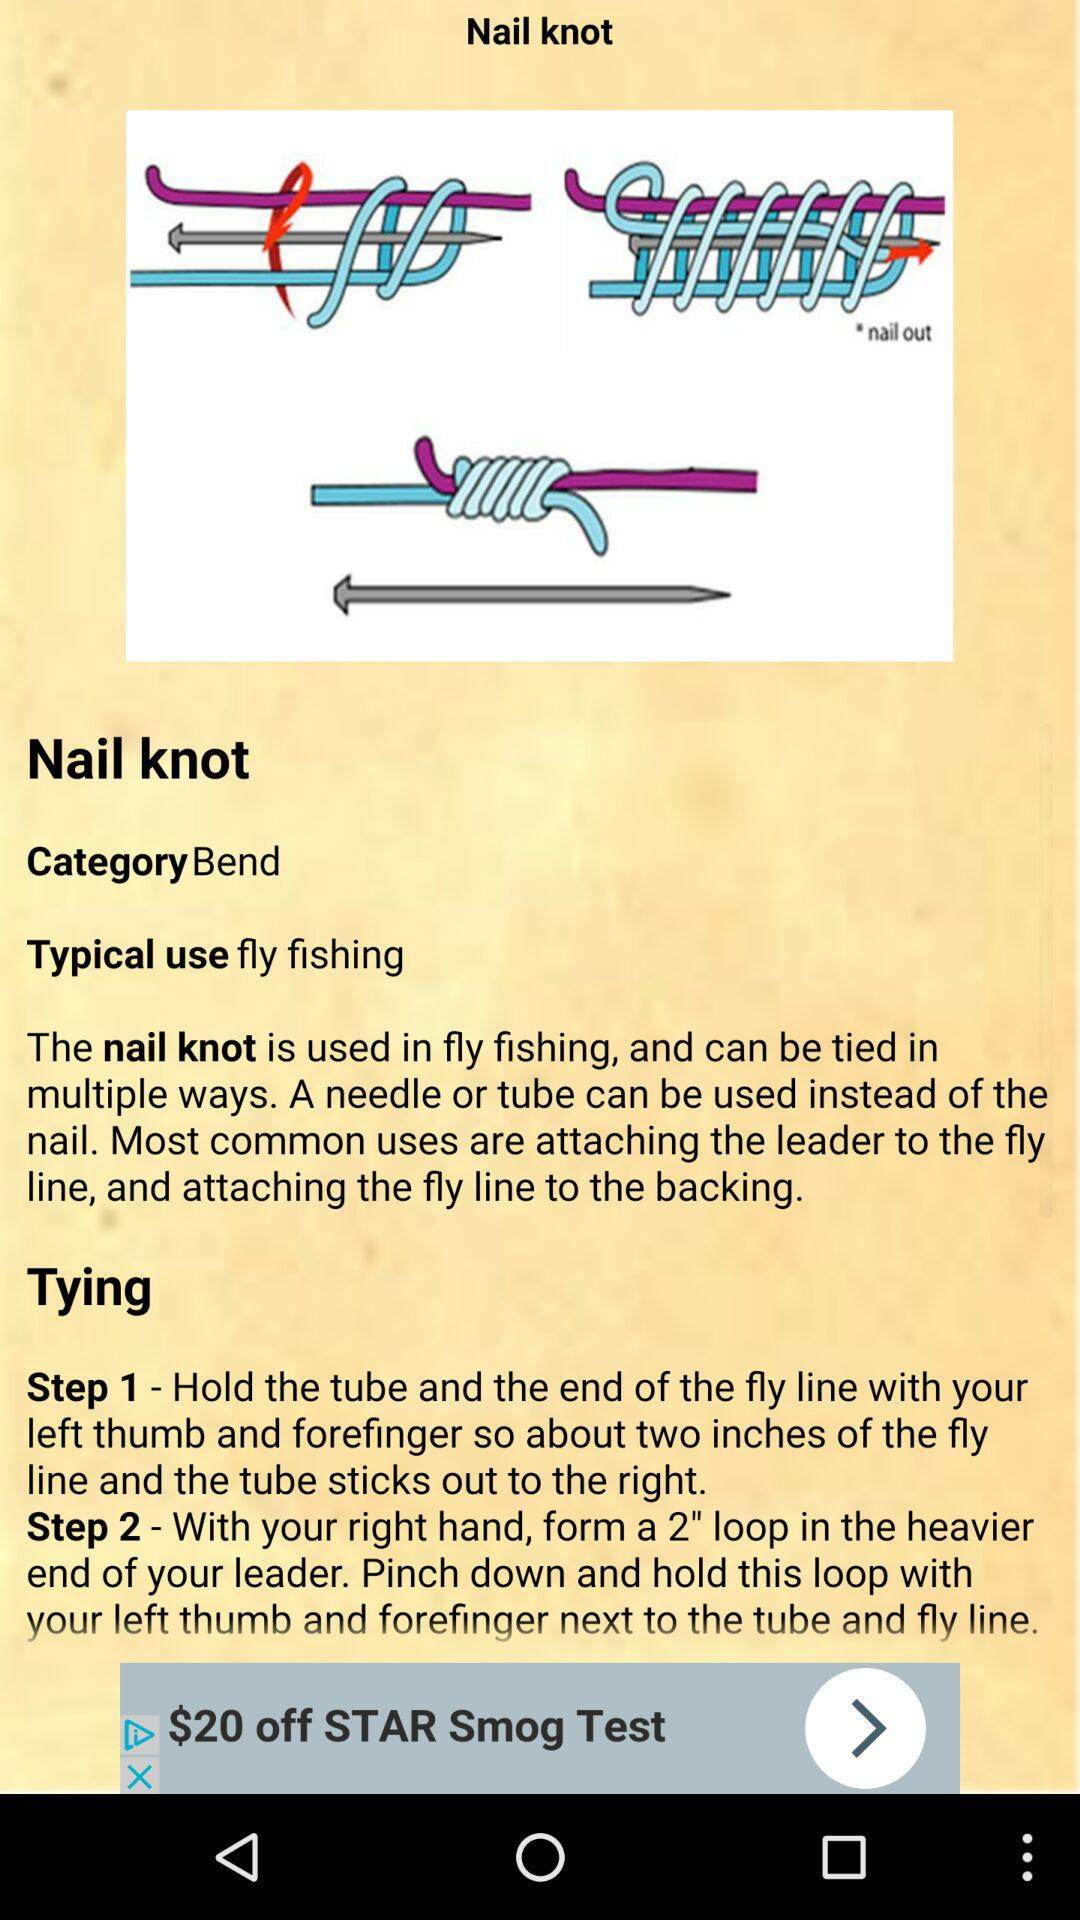How many different types of materials can be used instead of a nail?
Answer the question using a single word or phrase. 2 